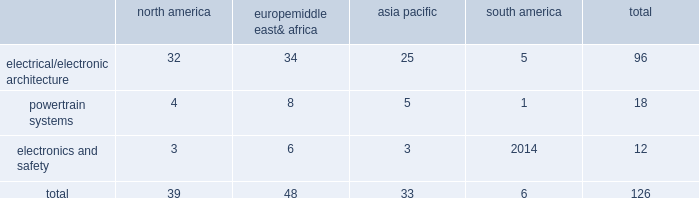Taxing authorities could challenge our historical and future tax positions .
Our future effective tax rates could be affected by changes in the mix of earnings in countries with differing statutory rates and changes in tax laws or their interpretation including changes related to tax holidays or tax incentives .
Our taxes could increase if certain tax holidays or incentives are not renewed upon expiration , or if tax rates or regimes applicable to us in such jurisdictions are otherwise increased .
The amount of tax we pay is subject to our interpretation of applicable tax laws in the jurisdictions in which we file .
We have taken and will continue to take tax positions based on our interpretation of such tax laws .
In particular , we will seek to organize and operate ourselves in such a way that we are and remain tax resident in the united kingdom .
Additionally , in determining the adequacy of our provision for income taxes , we regularly assess the likelihood of adverse outcomes resulting from tax examinations .
While it is often difficult to predict the final outcome or the timing of the resolution of a tax examination , our reserves for uncertain tax benefits reflect the outcome of tax positions that are more likely than not to occur .
While we believe that we have complied with all applicable tax laws , there can be no assurance that a taxing authority will not have a different interpretation of the law and assess us with additional taxes .
Should additional taxes be assessed , this may result in a material adverse effect on our results of operations and financial condition .
Item 1b .
Unresolved staff comments we have no unresolved sec staff comments to report .
Item 2 .
Properties as of december 31 , 2016 , we owned or leased 126 major manufacturing sites and 15 major technical centers .
A manufacturing site may include multiple plants and may be wholly or partially owned or leased .
We also have many smaller manufacturing sites , sales offices , warehouses , engineering centers , joint ventures and other investments strategically located throughout the world .
We have a presence in 46 countries .
The table shows the regional distribution of our major manufacturing sites by the operating segment that uses such facilities : north america europe , middle east & africa asia pacific south america total .
In addition to these manufacturing sites , we had 15 major technical centers : five in north america ; five in europe , middle east and africa ; four in asia pacific ; and one in south america .
Of our 126 major manufacturing sites and 15 major technical centers , which include facilities owned or leased by our consolidated subsidiaries , 75 are primarily owned and 66 are primarily leased .
We frequently review our real estate portfolio and develop footprint strategies to support our customers 2019 global plans , while at the same time supporting our technical needs and controlling operating expenses .
We believe our evolving portfolio will meet current and anticipated future needs .
Item 3 .
Legal proceedings we are from time to time subject to various actions , claims , suits , government investigations , and other proceedings incidental to our business , including those arising out of alleged defects , breach of contracts , competition and antitrust matters , product warranties , intellectual property matters , personal injury claims and employment-related matters .
It is our opinion that the outcome of such matters will not have a material adverse impact on our consolidated financial position , results of operations , or cash flows .
With respect to warranty matters , although we cannot ensure that the future costs of warranty claims by customers will not be material , we believe our established reserves are adequate to cover potential warranty settlements .
However , the final amounts required to resolve these matters could differ materially from our recorded estimates. .
What percentage of major manufacturing sites are in europe middle east& africa? 
Computations: (48 / 126)
Answer: 0.38095. 